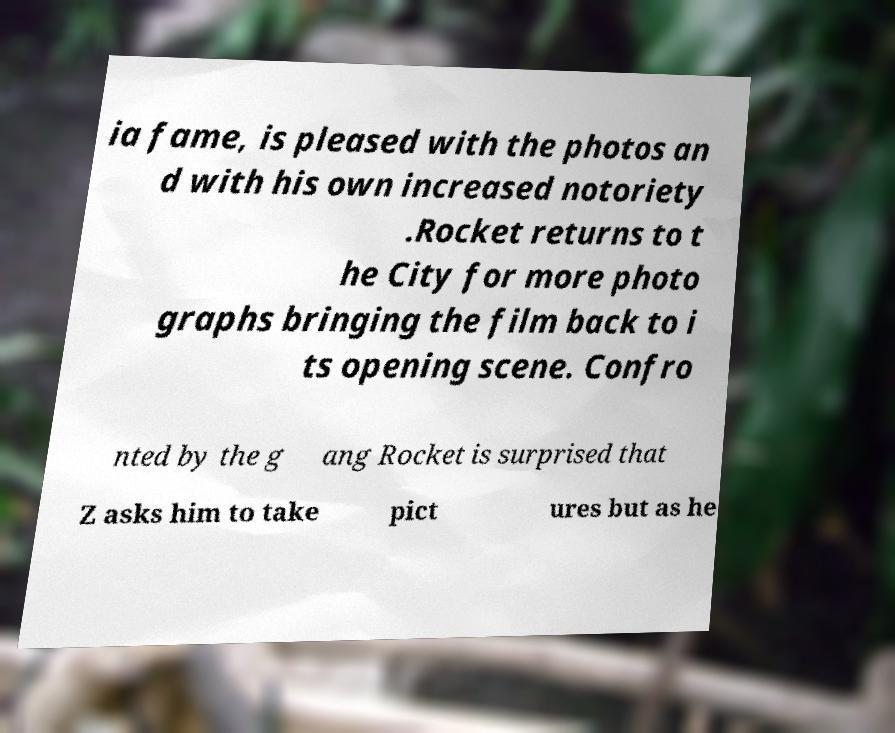Please read and relay the text visible in this image. What does it say? ia fame, is pleased with the photos an d with his own increased notoriety .Rocket returns to t he City for more photo graphs bringing the film back to i ts opening scene. Confro nted by the g ang Rocket is surprised that Z asks him to take pict ures but as he 